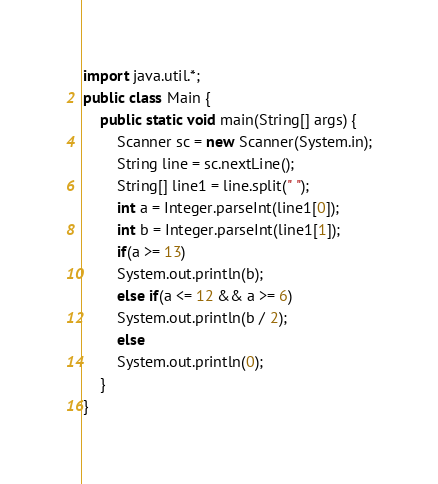Convert code to text. <code><loc_0><loc_0><loc_500><loc_500><_Java_>import java.util.*;
public class Main {
    public static void main(String[] args) {
        Scanner sc = new Scanner(System.in);
        String line = sc.nextLine();
        String[] line1 = line.split(" ");
        int a = Integer.parseInt(line1[0]);
        int b = Integer.parseInt(line1[1]);
        if(a >= 13)
        System.out.println(b);
        else if(a <= 12 && a >= 6)
        System.out.println(b / 2);
        else
        System.out.println(0);
    }
}</code> 